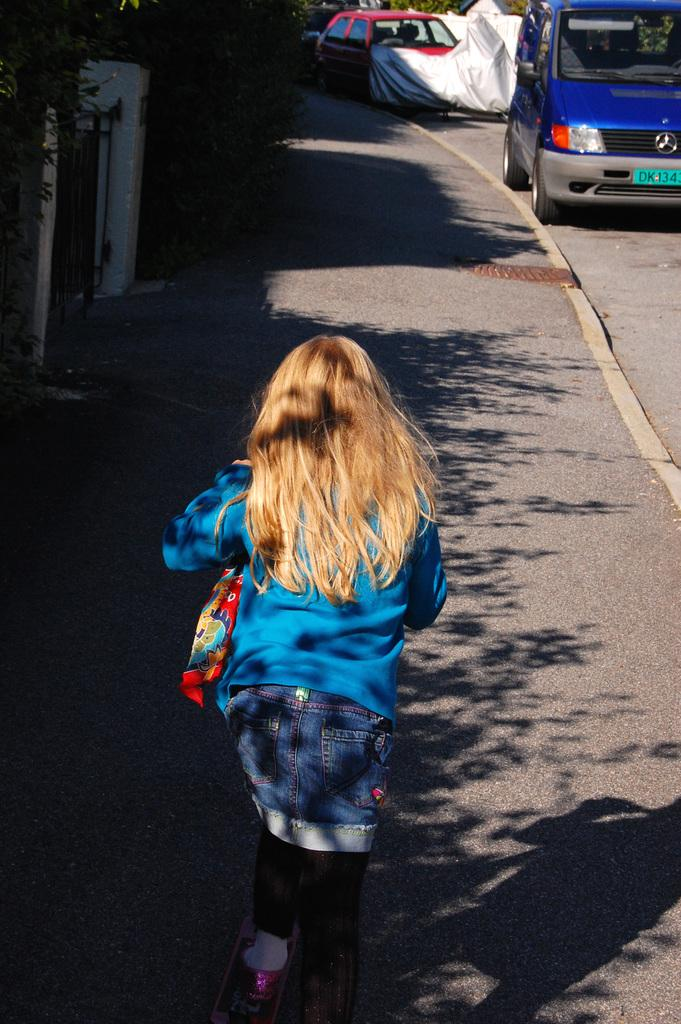Who is the main subject in the image? There is a girl in the image. What is the girl wearing? The girl is wearing a bag. What is the girl doing in the image? The girl is running on a walkway. What can be seen in the background of the image? There are cars in the background of the image. What type of vegetation is on the left side of the image? There are plants on the left side of the image. How does the earthquake affect the girl in the image? There is no earthquake present in the image, so its effect on the girl cannot be determined. 